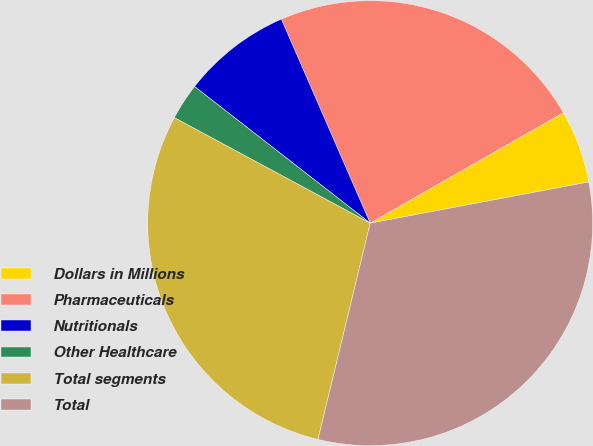Convert chart. <chart><loc_0><loc_0><loc_500><loc_500><pie_chart><fcel>Dollars in Millions<fcel>Pharmaceuticals<fcel>Nutritionals<fcel>Other Healthcare<fcel>Total segments<fcel>Total<nl><fcel>5.3%<fcel>23.27%<fcel>7.94%<fcel>2.66%<fcel>29.09%<fcel>31.73%<nl></chart> 